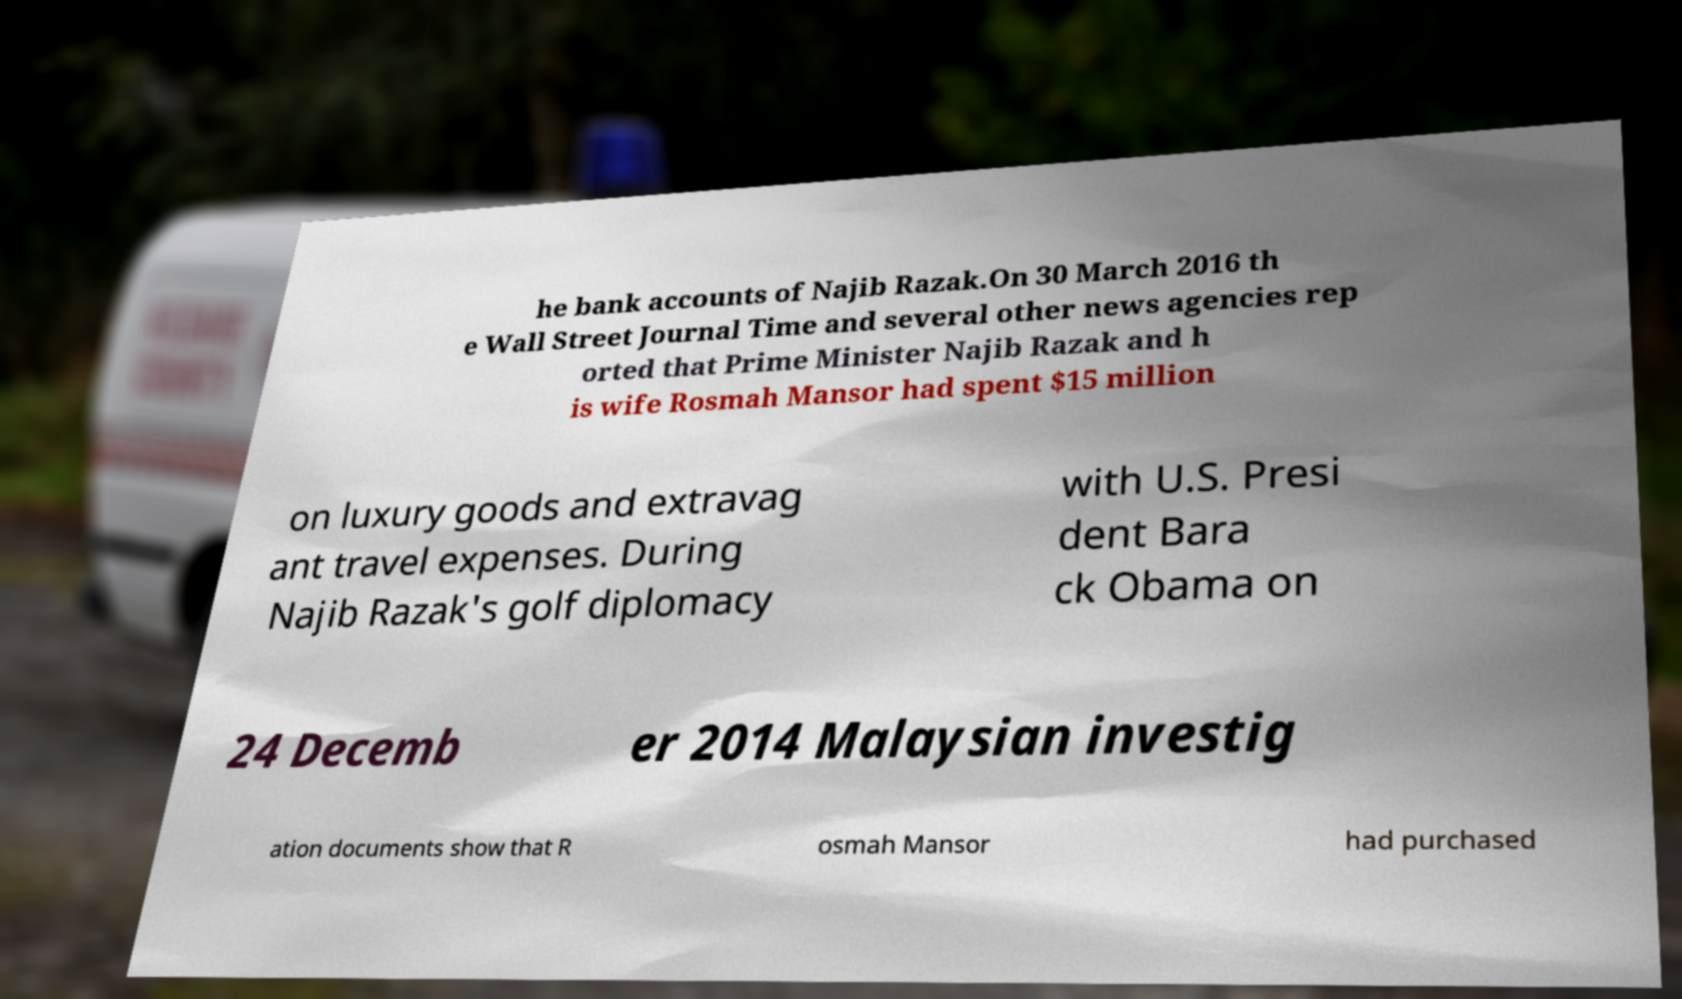Can you read and provide the text displayed in the image?This photo seems to have some interesting text. Can you extract and type it out for me? he bank accounts of Najib Razak.On 30 March 2016 th e Wall Street Journal Time and several other news agencies rep orted that Prime Minister Najib Razak and h is wife Rosmah Mansor had spent $15 million on luxury goods and extravag ant travel expenses. During Najib Razak's golf diplomacy with U.S. Presi dent Bara ck Obama on 24 Decemb er 2014 Malaysian investig ation documents show that R osmah Mansor had purchased 